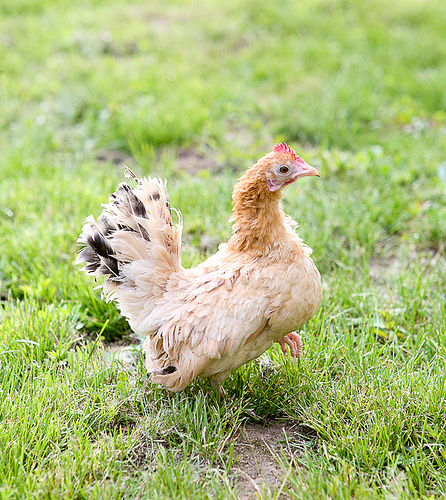<image>
Is the hen on the grass? Yes. Looking at the image, I can see the hen is positioned on top of the grass, with the grass providing support. Where is the ground in relation to the chicken? Is it under the chicken? Yes. The ground is positioned underneath the chicken, with the chicken above it in the vertical space. Where is the chicken in relation to the grass? Is it behind the grass? No. The chicken is not behind the grass. From this viewpoint, the chicken appears to be positioned elsewhere in the scene. 